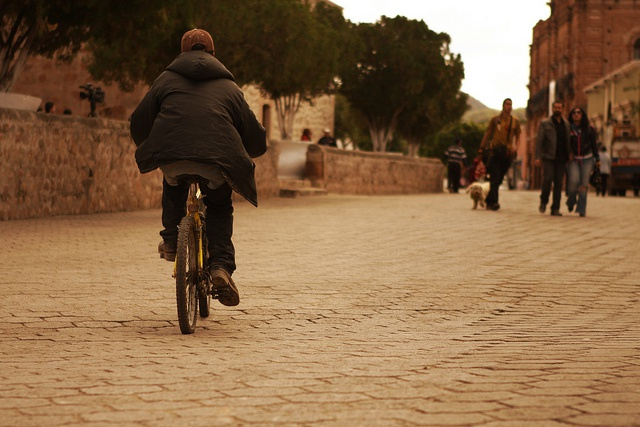Describe the objects in this image and their specific colors. I can see people in black, maroon, and brown tones, bicycle in black, maroon, and brown tones, people in black, maroon, and gray tones, people in black, maroon, and brown tones, and people in black, maroon, and brown tones in this image. 